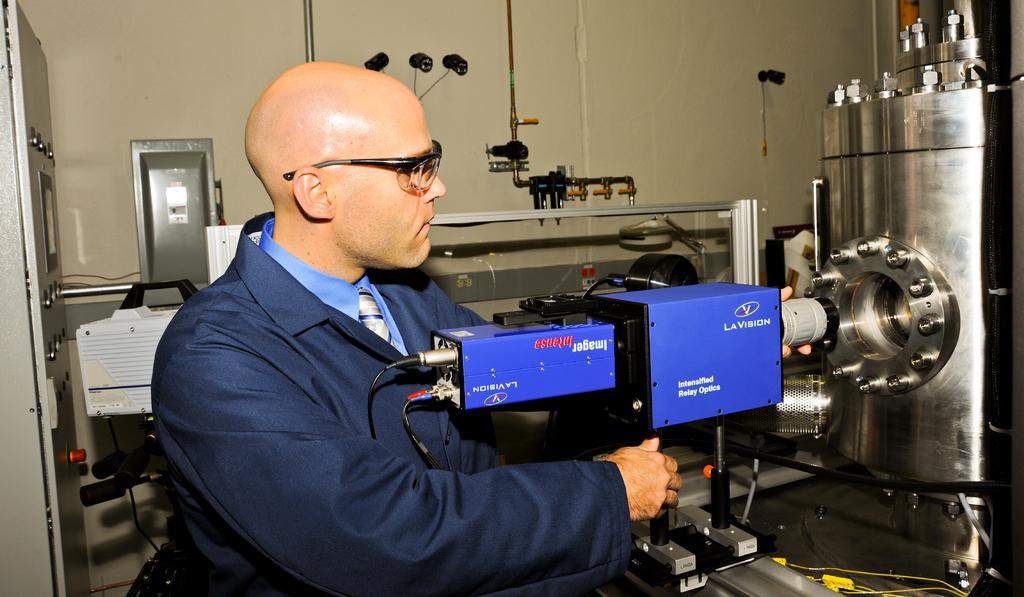What is the man in the image doing? The man is operating a machine in the image. What type of clothing is the man wearing? The man is wearing a coat, a tie, and a shirt in the image. What accessory is the man wearing on his face? The man is wearing spectacles in the image. What type of drug is the man taking in the image? There is no indication of any drug in the image; the man is operating a machine and wearing specific clothing items. 